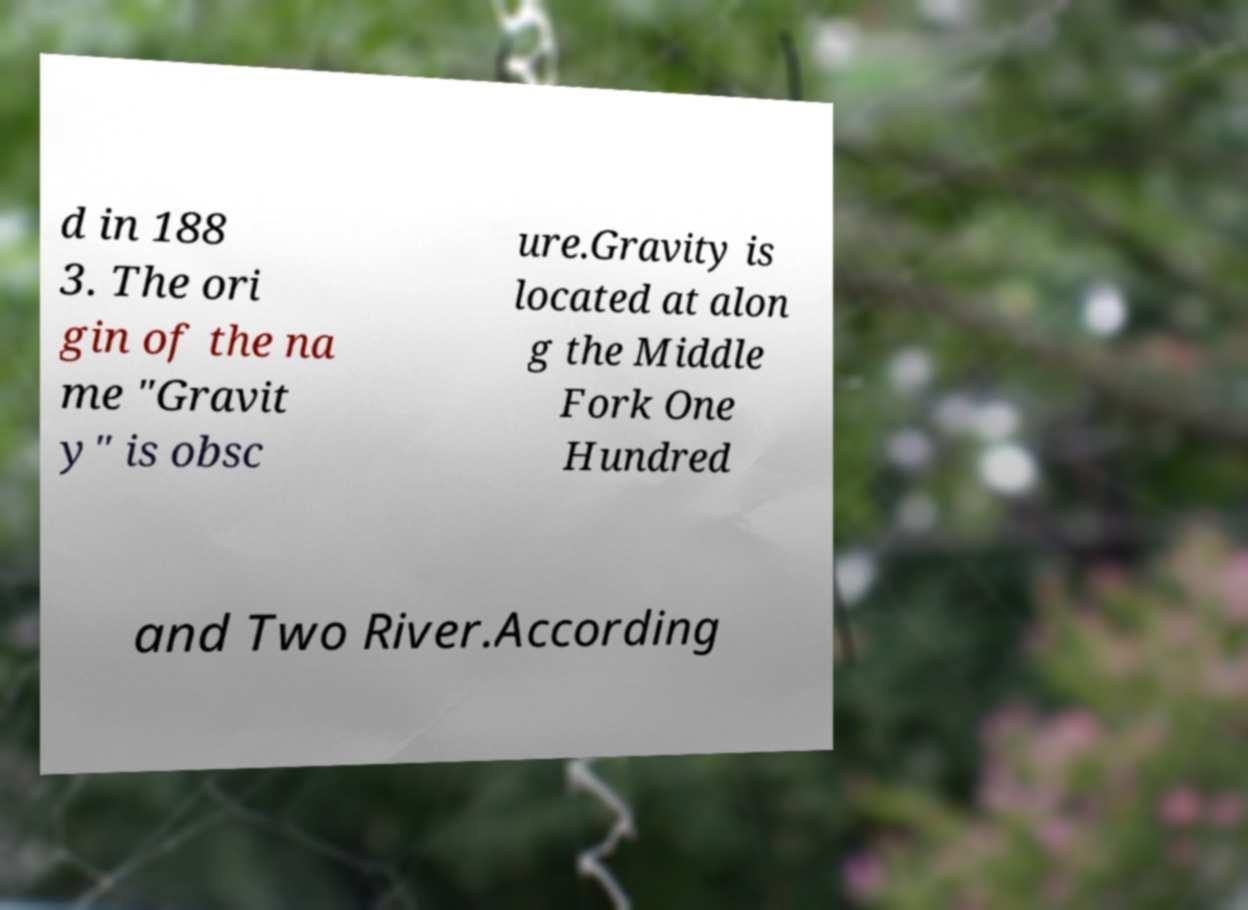For documentation purposes, I need the text within this image transcribed. Could you provide that? d in 188 3. The ori gin of the na me "Gravit y" is obsc ure.Gravity is located at alon g the Middle Fork One Hundred and Two River.According 